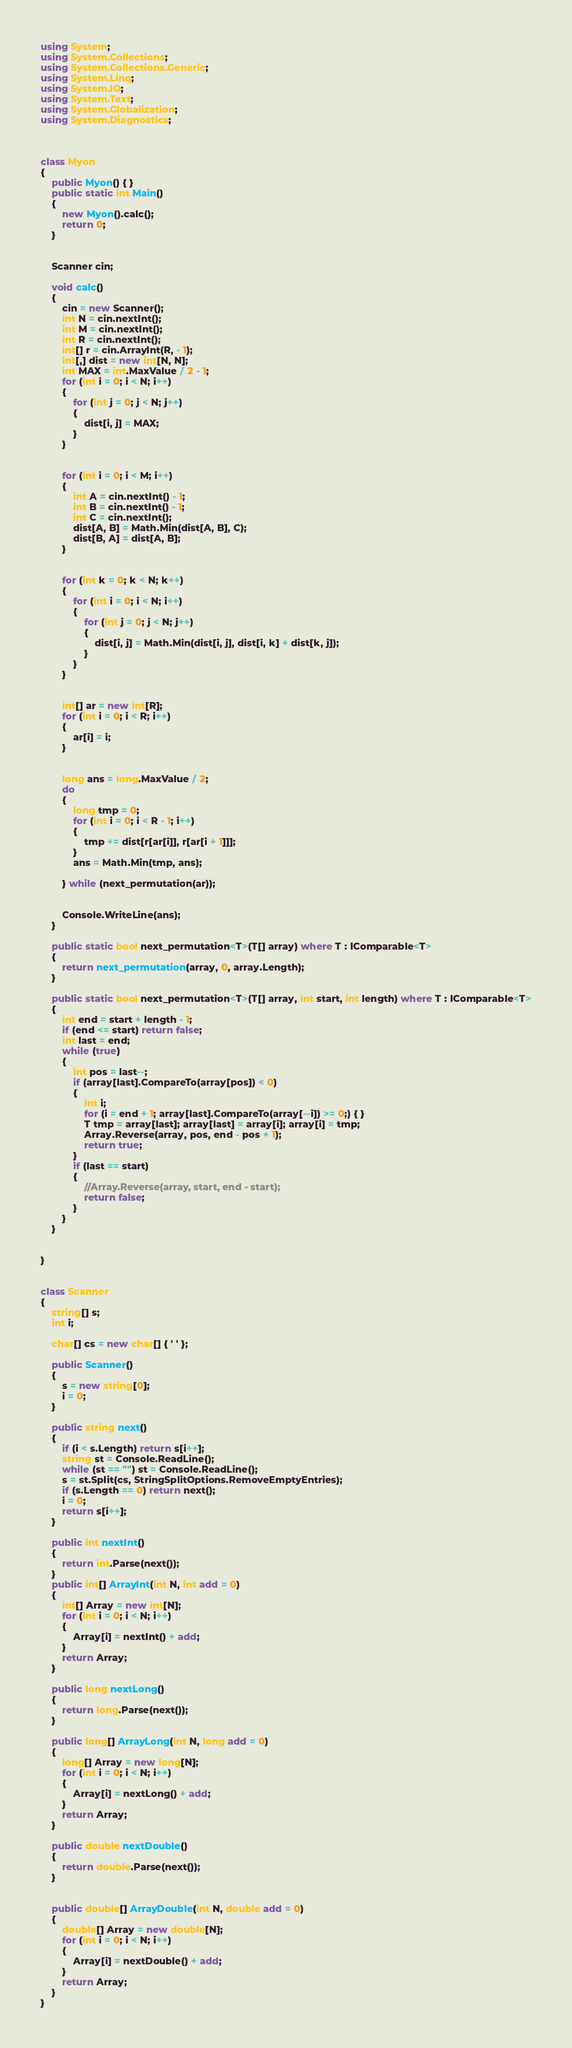<code> <loc_0><loc_0><loc_500><loc_500><_C#_>using System;
using System.Collections;
using System.Collections.Generic;
using System.Linq;
using System.IO;
using System.Text;
using System.Globalization;
using System.Diagnostics;



class Myon
{
    public Myon() { }
    public static int Main()
    {
        new Myon().calc();
        return 0;
    }
    

    Scanner cin;

    void calc()
    {
        cin = new Scanner();
        int N = cin.nextInt();
        int M = cin.nextInt();
        int R = cin.nextInt();
        int[] r = cin.ArrayInt(R, - 1);
        int[,] dist = new int[N, N];
        int MAX = int.MaxValue / 2 - 1;
        for (int i = 0; i < N; i++)
        {
            for (int j = 0; j < N; j++)
            {
                dist[i, j] = MAX;
            }
        }


        for (int i = 0; i < M; i++)
        {
            int A = cin.nextInt() - 1;
            int B = cin.nextInt() - 1;
            int C = cin.nextInt();
            dist[A, B] = Math.Min(dist[A, B], C);
            dist[B, A] = dist[A, B];
        }


        for (int k = 0; k < N; k++)
        {
            for (int i = 0; i < N; i++)
            {
                for (int j = 0; j < N; j++)
                {
                    dist[i, j] = Math.Min(dist[i, j], dist[i, k] + dist[k, j]);
                }
            }
        }


        int[] ar = new int[R];
        for (int i = 0; i < R; i++)
        {
            ar[i] = i;
        }


        long ans = long.MaxValue / 2;
        do
        {
            long tmp = 0;
            for (int i = 0; i < R - 1; i++)
            {
                tmp += dist[r[ar[i]], r[ar[i + 1]]];
            }
            ans = Math.Min(tmp, ans);

        } while (next_permutation(ar));


        Console.WriteLine(ans);
    }

    public static bool next_permutation<T>(T[] array) where T : IComparable<T>
    {
        return next_permutation(array, 0, array.Length);
    }

    public static bool next_permutation<T>(T[] array, int start, int length) where T : IComparable<T>
    {
        int end = start + length - 1;
        if (end <= start) return false;
        int last = end;
        while (true)
        {
            int pos = last--;
            if (array[last].CompareTo(array[pos]) < 0)
            {
                int i;
                for (i = end + 1; array[last].CompareTo(array[--i]) >= 0;) { }
                T tmp = array[last]; array[last] = array[i]; array[i] = tmp;
                Array.Reverse(array, pos, end - pos + 1);
                return true;
            }
            if (last == start)
            {
                //Array.Reverse(array, start, end - start);
                return false;
            }
        }
    }


}


class Scanner
{
    string[] s;
    int i;

    char[] cs = new char[] { ' ' };

    public Scanner()
    {
        s = new string[0];
        i = 0;
    }

    public string next()
    {
        if (i < s.Length) return s[i++];
        string st = Console.ReadLine();
        while (st == "") st = Console.ReadLine();
        s = st.Split(cs, StringSplitOptions.RemoveEmptyEntries);
        if (s.Length == 0) return next();
        i = 0;
        return s[i++];
    }

    public int nextInt()
    {
        return int.Parse(next());
    }
    public int[] ArrayInt(int N, int add = 0)
    {
        int[] Array = new int[N];
        for (int i = 0; i < N; i++)
        {
            Array[i] = nextInt() + add;
        }
        return Array;
    }

    public long nextLong()
    {
        return long.Parse(next());
    }

    public long[] ArrayLong(int N, long add = 0)
    {
        long[] Array = new long[N];
        for (int i = 0; i < N; i++)
        {
            Array[i] = nextLong() + add;
        }
        return Array;
    }

    public double nextDouble()
    {
        return double.Parse(next());
    }


    public double[] ArrayDouble(int N, double add = 0)
    {
        double[] Array = new double[N];
        for (int i = 0; i < N; i++)
        {
            Array[i] = nextDouble() + add;
        }
        return Array;
    }
}
</code> 